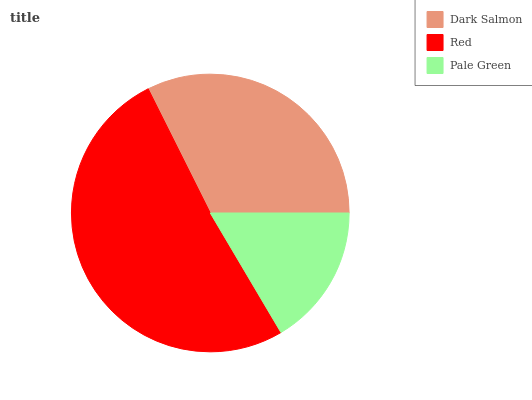Is Pale Green the minimum?
Answer yes or no. Yes. Is Red the maximum?
Answer yes or no. Yes. Is Red the minimum?
Answer yes or no. No. Is Pale Green the maximum?
Answer yes or no. No. Is Red greater than Pale Green?
Answer yes or no. Yes. Is Pale Green less than Red?
Answer yes or no. Yes. Is Pale Green greater than Red?
Answer yes or no. No. Is Red less than Pale Green?
Answer yes or no. No. Is Dark Salmon the high median?
Answer yes or no. Yes. Is Dark Salmon the low median?
Answer yes or no. Yes. Is Red the high median?
Answer yes or no. No. Is Pale Green the low median?
Answer yes or no. No. 